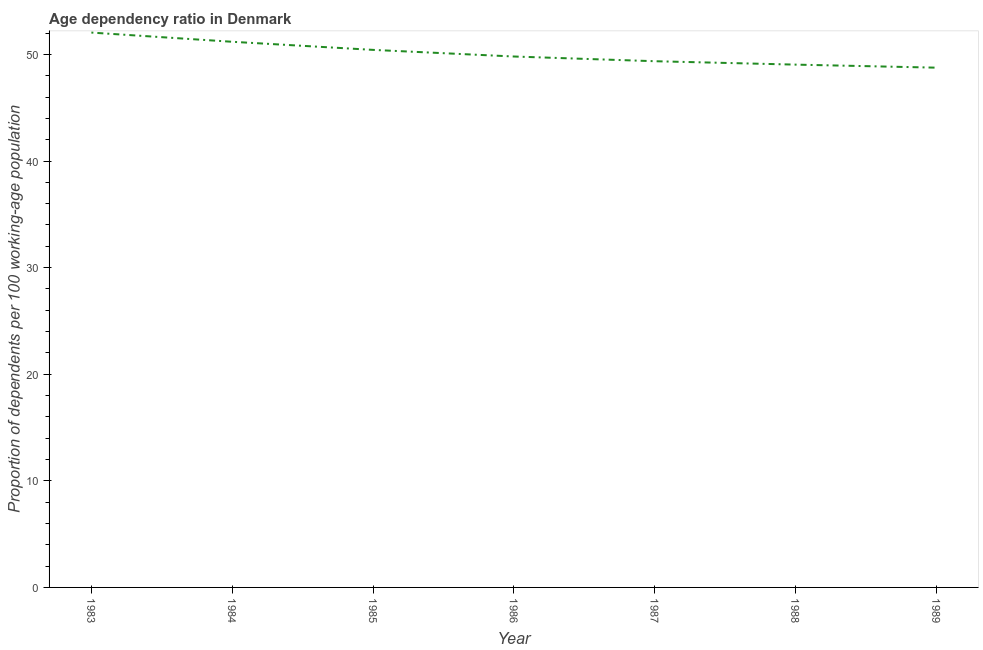What is the age dependency ratio in 1985?
Give a very brief answer. 50.43. Across all years, what is the maximum age dependency ratio?
Give a very brief answer. 52.05. Across all years, what is the minimum age dependency ratio?
Offer a terse response. 48.76. In which year was the age dependency ratio maximum?
Make the answer very short. 1983. What is the sum of the age dependency ratio?
Provide a succinct answer. 350.63. What is the difference between the age dependency ratio in 1983 and 1989?
Your answer should be very brief. 3.29. What is the average age dependency ratio per year?
Offer a very short reply. 50.09. What is the median age dependency ratio?
Offer a very short reply. 49.81. In how many years, is the age dependency ratio greater than 2 ?
Provide a succinct answer. 7. Do a majority of the years between 1986 and 1984 (inclusive) have age dependency ratio greater than 44 ?
Keep it short and to the point. No. What is the ratio of the age dependency ratio in 1985 to that in 1987?
Provide a short and direct response. 1.02. Is the age dependency ratio in 1986 less than that in 1988?
Your response must be concise. No. What is the difference between the highest and the second highest age dependency ratio?
Your response must be concise. 0.86. What is the difference between the highest and the lowest age dependency ratio?
Offer a terse response. 3.29. In how many years, is the age dependency ratio greater than the average age dependency ratio taken over all years?
Ensure brevity in your answer.  3. Does the age dependency ratio monotonically increase over the years?
Offer a very short reply. No. How many lines are there?
Give a very brief answer. 1. What is the title of the graph?
Provide a succinct answer. Age dependency ratio in Denmark. What is the label or title of the X-axis?
Ensure brevity in your answer.  Year. What is the label or title of the Y-axis?
Provide a succinct answer. Proportion of dependents per 100 working-age population. What is the Proportion of dependents per 100 working-age population of 1983?
Keep it short and to the point. 52.05. What is the Proportion of dependents per 100 working-age population in 1984?
Your answer should be very brief. 51.19. What is the Proportion of dependents per 100 working-age population in 1985?
Make the answer very short. 50.43. What is the Proportion of dependents per 100 working-age population of 1986?
Your answer should be very brief. 49.81. What is the Proportion of dependents per 100 working-age population of 1987?
Ensure brevity in your answer.  49.36. What is the Proportion of dependents per 100 working-age population in 1988?
Ensure brevity in your answer.  49.04. What is the Proportion of dependents per 100 working-age population in 1989?
Ensure brevity in your answer.  48.76. What is the difference between the Proportion of dependents per 100 working-age population in 1983 and 1984?
Offer a very short reply. 0.86. What is the difference between the Proportion of dependents per 100 working-age population in 1983 and 1985?
Your answer should be compact. 1.62. What is the difference between the Proportion of dependents per 100 working-age population in 1983 and 1986?
Your response must be concise. 2.24. What is the difference between the Proportion of dependents per 100 working-age population in 1983 and 1987?
Offer a terse response. 2.69. What is the difference between the Proportion of dependents per 100 working-age population in 1983 and 1988?
Provide a short and direct response. 3.01. What is the difference between the Proportion of dependents per 100 working-age population in 1983 and 1989?
Provide a succinct answer. 3.29. What is the difference between the Proportion of dependents per 100 working-age population in 1984 and 1985?
Provide a succinct answer. 0.76. What is the difference between the Proportion of dependents per 100 working-age population in 1984 and 1986?
Give a very brief answer. 1.38. What is the difference between the Proportion of dependents per 100 working-age population in 1984 and 1987?
Keep it short and to the point. 1.82. What is the difference between the Proportion of dependents per 100 working-age population in 1984 and 1988?
Provide a succinct answer. 2.14. What is the difference between the Proportion of dependents per 100 working-age population in 1984 and 1989?
Provide a short and direct response. 2.43. What is the difference between the Proportion of dependents per 100 working-age population in 1985 and 1986?
Make the answer very short. 0.62. What is the difference between the Proportion of dependents per 100 working-age population in 1985 and 1987?
Give a very brief answer. 1.06. What is the difference between the Proportion of dependents per 100 working-age population in 1985 and 1988?
Your answer should be compact. 1.38. What is the difference between the Proportion of dependents per 100 working-age population in 1985 and 1989?
Your response must be concise. 1.67. What is the difference between the Proportion of dependents per 100 working-age population in 1986 and 1987?
Provide a succinct answer. 0.44. What is the difference between the Proportion of dependents per 100 working-age population in 1986 and 1988?
Offer a very short reply. 0.76. What is the difference between the Proportion of dependents per 100 working-age population in 1986 and 1989?
Your answer should be compact. 1.05. What is the difference between the Proportion of dependents per 100 working-age population in 1987 and 1988?
Provide a short and direct response. 0.32. What is the difference between the Proportion of dependents per 100 working-age population in 1987 and 1989?
Your answer should be compact. 0.6. What is the difference between the Proportion of dependents per 100 working-age population in 1988 and 1989?
Keep it short and to the point. 0.29. What is the ratio of the Proportion of dependents per 100 working-age population in 1983 to that in 1985?
Offer a very short reply. 1.03. What is the ratio of the Proportion of dependents per 100 working-age population in 1983 to that in 1986?
Give a very brief answer. 1.04. What is the ratio of the Proportion of dependents per 100 working-age population in 1983 to that in 1987?
Provide a short and direct response. 1.05. What is the ratio of the Proportion of dependents per 100 working-age population in 1983 to that in 1988?
Provide a succinct answer. 1.06. What is the ratio of the Proportion of dependents per 100 working-age population in 1983 to that in 1989?
Offer a very short reply. 1.07. What is the ratio of the Proportion of dependents per 100 working-age population in 1984 to that in 1985?
Your response must be concise. 1.01. What is the ratio of the Proportion of dependents per 100 working-age population in 1984 to that in 1986?
Keep it short and to the point. 1.03. What is the ratio of the Proportion of dependents per 100 working-age population in 1984 to that in 1987?
Provide a short and direct response. 1.04. What is the ratio of the Proportion of dependents per 100 working-age population in 1984 to that in 1988?
Your answer should be compact. 1.04. What is the ratio of the Proportion of dependents per 100 working-age population in 1985 to that in 1986?
Provide a succinct answer. 1.01. What is the ratio of the Proportion of dependents per 100 working-age population in 1985 to that in 1988?
Offer a very short reply. 1.03. What is the ratio of the Proportion of dependents per 100 working-age population in 1985 to that in 1989?
Make the answer very short. 1.03. What is the ratio of the Proportion of dependents per 100 working-age population in 1986 to that in 1987?
Give a very brief answer. 1.01. What is the ratio of the Proportion of dependents per 100 working-age population in 1986 to that in 1988?
Provide a succinct answer. 1.02. What is the ratio of the Proportion of dependents per 100 working-age population in 1987 to that in 1988?
Make the answer very short. 1.01. What is the ratio of the Proportion of dependents per 100 working-age population in 1988 to that in 1989?
Ensure brevity in your answer.  1.01. 